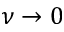<formula> <loc_0><loc_0><loc_500><loc_500>\nu \to 0</formula> 